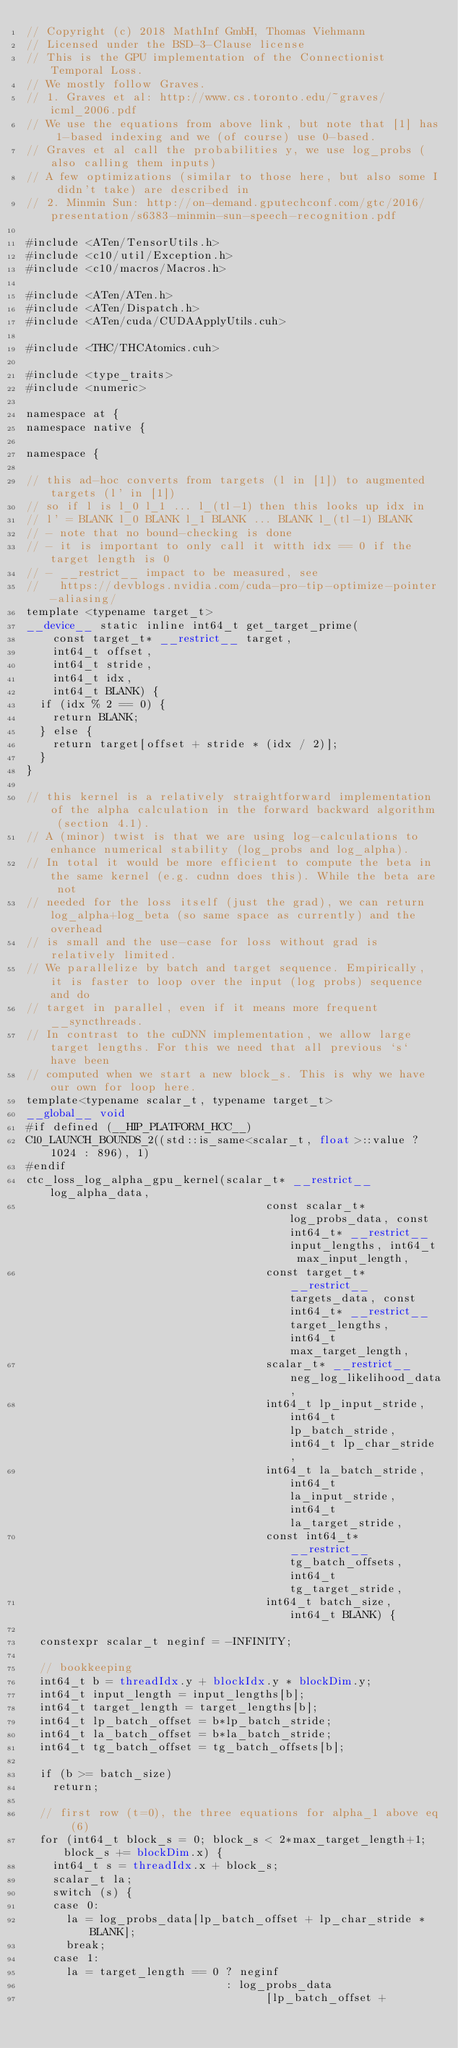<code> <loc_0><loc_0><loc_500><loc_500><_Cuda_>// Copyright (c) 2018 MathInf GmbH, Thomas Viehmann
// Licensed under the BSD-3-Clause license
// This is the GPU implementation of the Connectionist Temporal Loss.
// We mostly follow Graves.
// 1. Graves et al: http://www.cs.toronto.edu/~graves/icml_2006.pdf
// We use the equations from above link, but note that [1] has 1-based indexing and we (of course) use 0-based.
// Graves et al call the probabilities y, we use log_probs (also calling them inputs)
// A few optimizations (similar to those here, but also some I didn't take) are described in
// 2. Minmin Sun: http://on-demand.gputechconf.com/gtc/2016/presentation/s6383-minmin-sun-speech-recognition.pdf

#include <ATen/TensorUtils.h>
#include <c10/util/Exception.h>
#include <c10/macros/Macros.h>

#include <ATen/ATen.h>
#include <ATen/Dispatch.h>
#include <ATen/cuda/CUDAApplyUtils.cuh>

#include <THC/THCAtomics.cuh>

#include <type_traits>
#include <numeric>

namespace at {
namespace native {

namespace {

// this ad-hoc converts from targets (l in [1]) to augmented targets (l' in [1])
// so if l is l_0 l_1 ... l_(tl-1) then this looks up idx in
// l' = BLANK l_0 BLANK l_1 BLANK ... BLANK l_(tl-1) BLANK
// - note that no bound-checking is done
// - it is important to only call it witth idx == 0 if the target length is 0
// - __restrict__ impact to be measured, see
//   https://devblogs.nvidia.com/cuda-pro-tip-optimize-pointer-aliasing/
template <typename target_t>
__device__ static inline int64_t get_target_prime(
    const target_t* __restrict__ target,
    int64_t offset,
    int64_t stride,
    int64_t idx,
    int64_t BLANK) {
  if (idx % 2 == 0) {
    return BLANK;
  } else {
    return target[offset + stride * (idx / 2)];
  }
}

// this kernel is a relatively straightforward implementation of the alpha calculation in the forward backward algorithm (section 4.1).
// A (minor) twist is that we are using log-calculations to enhance numerical stability (log_probs and log_alpha).
// In total it would be more efficient to compute the beta in the same kernel (e.g. cudnn does this). While the beta are not
// needed for the loss itself (just the grad), we can return log_alpha+log_beta (so same space as currently) and the overhead
// is small and the use-case for loss without grad is relatively limited.
// We parallelize by batch and target sequence. Empirically, it is faster to loop over the input (log probs) sequence  and do
// target in parallel, even if it means more frequent __syncthreads.
// In contrast to the cuDNN implementation, we allow large target lengths. For this we need that all previous `s` have been
// computed when we start a new block_s. This is why we have our own for loop here.
template<typename scalar_t, typename target_t>
__global__ void
#if defined (__HIP_PLATFORM_HCC__)
C10_LAUNCH_BOUNDS_2((std::is_same<scalar_t, float>::value ? 1024 : 896), 1)
#endif
ctc_loss_log_alpha_gpu_kernel(scalar_t* __restrict__ log_alpha_data,
                                    const scalar_t*log_probs_data, const int64_t* __restrict__ input_lengths, int64_t max_input_length,
                                    const target_t* __restrict__ targets_data, const int64_t* __restrict__ target_lengths, int64_t max_target_length,
                                    scalar_t* __restrict__ neg_log_likelihood_data,
                                    int64_t lp_input_stride, int64_t lp_batch_stride, int64_t lp_char_stride,
                                    int64_t la_batch_stride, int64_t la_input_stride, int64_t la_target_stride,
                                    const int64_t* __restrict__ tg_batch_offsets, int64_t tg_target_stride,
                                    int64_t batch_size, int64_t BLANK) {

  constexpr scalar_t neginf = -INFINITY;

  // bookkeeping
  int64_t b = threadIdx.y + blockIdx.y * blockDim.y;
  int64_t input_length = input_lengths[b];
  int64_t target_length = target_lengths[b];
  int64_t lp_batch_offset = b*lp_batch_stride;
  int64_t la_batch_offset = b*la_batch_stride;
  int64_t tg_batch_offset = tg_batch_offsets[b];

  if (b >= batch_size)
    return;

  // first row (t=0), the three equations for alpha_1 above eq (6)
  for (int64_t block_s = 0; block_s < 2*max_target_length+1; block_s += blockDim.x) {
    int64_t s = threadIdx.x + block_s;
    scalar_t la;
    switch (s) {
    case 0:
      la = log_probs_data[lp_batch_offset + lp_char_stride * BLANK];
      break;
    case 1:
      la = target_length == 0 ? neginf
                              : log_probs_data
                                    [lp_batch_offset +</code> 